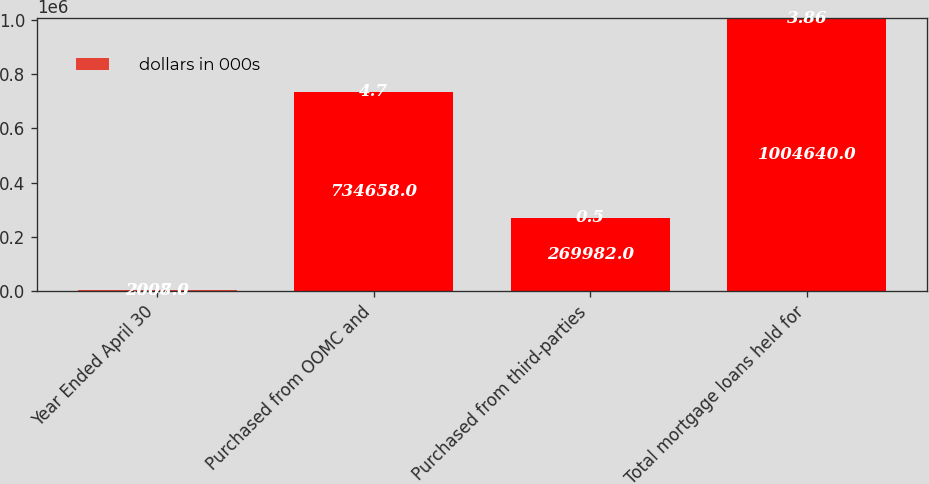Convert chart to OTSL. <chart><loc_0><loc_0><loc_500><loc_500><stacked_bar_chart><ecel><fcel>Year Ended April 30<fcel>Purchased from OOMC and<fcel>Purchased from third-parties<fcel>Total mortgage loans held for<nl><fcel>nan<fcel>2008<fcel>734658<fcel>269982<fcel>1.00464e+06<nl><fcel>dollars in 000s<fcel>2007<fcel>4.7<fcel>0.5<fcel>3.86<nl></chart> 